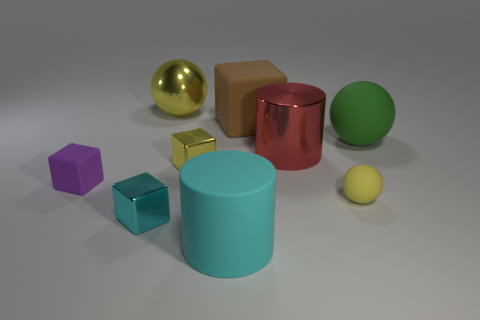The yellow object on the right side of the large matte object in front of the cylinder that is right of the brown matte cube is made of what material?
Provide a succinct answer. Rubber. There is a yellow ball behind the small rubber cube; what material is it?
Give a very brief answer. Metal. Is there a cyan thing of the same size as the brown rubber object?
Give a very brief answer. Yes. There is a large rubber thing in front of the purple matte thing; does it have the same color as the large shiny cylinder?
Your answer should be very brief. No. What number of yellow things are metallic blocks or small blocks?
Your answer should be compact. 1. What number of metal blocks have the same color as the small ball?
Offer a terse response. 1. Do the big yellow object and the tiny ball have the same material?
Make the answer very short. No. There is a large cyan thing that is in front of the small cyan block; how many metal cylinders are behind it?
Give a very brief answer. 1. Is the size of the cyan cylinder the same as the green ball?
Ensure brevity in your answer.  Yes. How many other big things have the same material as the big brown thing?
Provide a succinct answer. 2. 